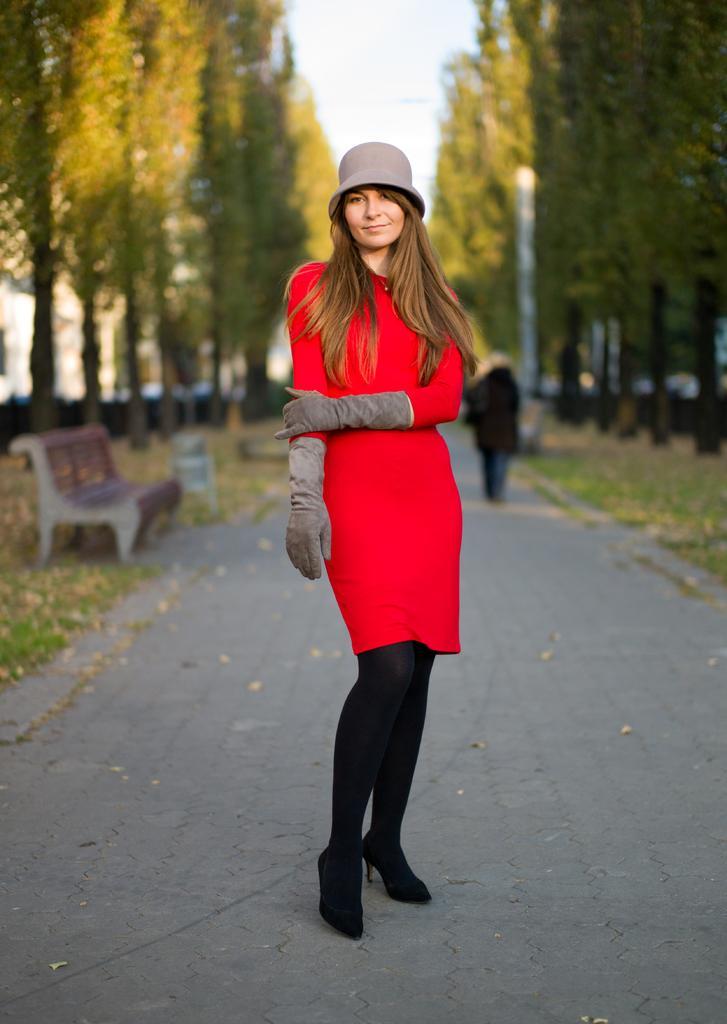How would you summarize this image in a sentence or two? In this picture I can see there is a woman standing here and there are trees in the backdrop. There is a bench and the sky is clear. 